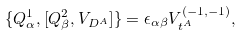Convert formula to latex. <formula><loc_0><loc_0><loc_500><loc_500>\{ { Q } ^ { 1 } _ { \alpha } , [ Q ^ { 2 } _ { \beta } , V _ { D ^ { A } } ] \} = \epsilon _ { \alpha \beta } V _ { t ^ { A } } ^ { ( - 1 , - 1 ) } ,</formula> 